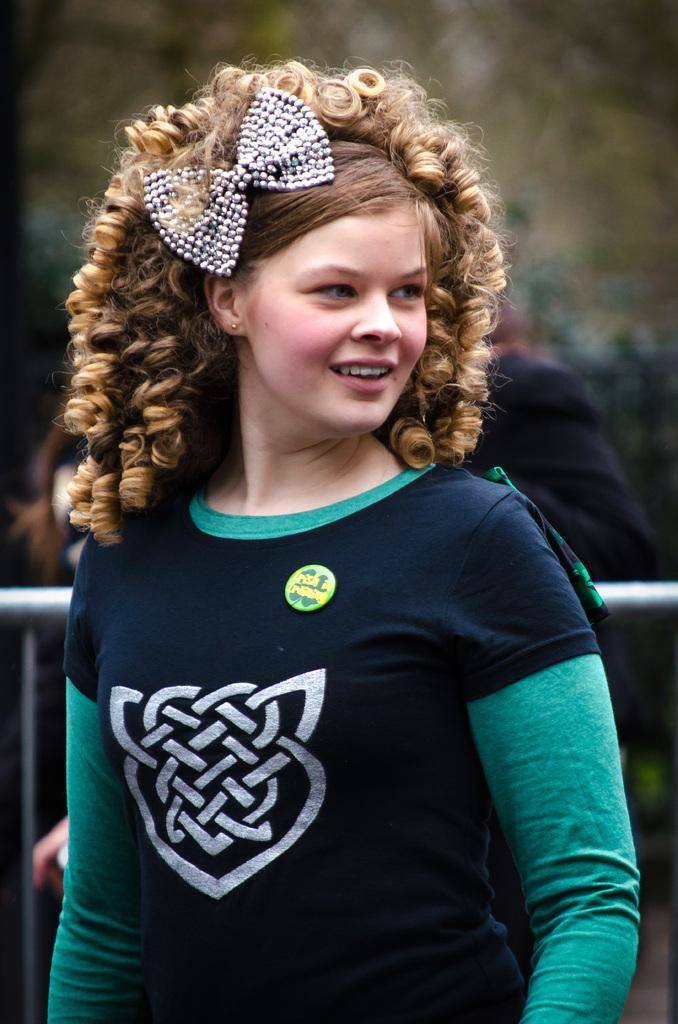Who is present in the image? There is a woman in the image. What is the woman doing in the image? The woman is standing in the image. What expression does the woman have in the image? The woman is smiling in the image. Can you describe the background of the image? The background of the image is blurry. What type of volleyball is the woman holding in the image? There is no volleyball present in the image. What type of poison is the woman using in the image? There is no poison present in the image. 